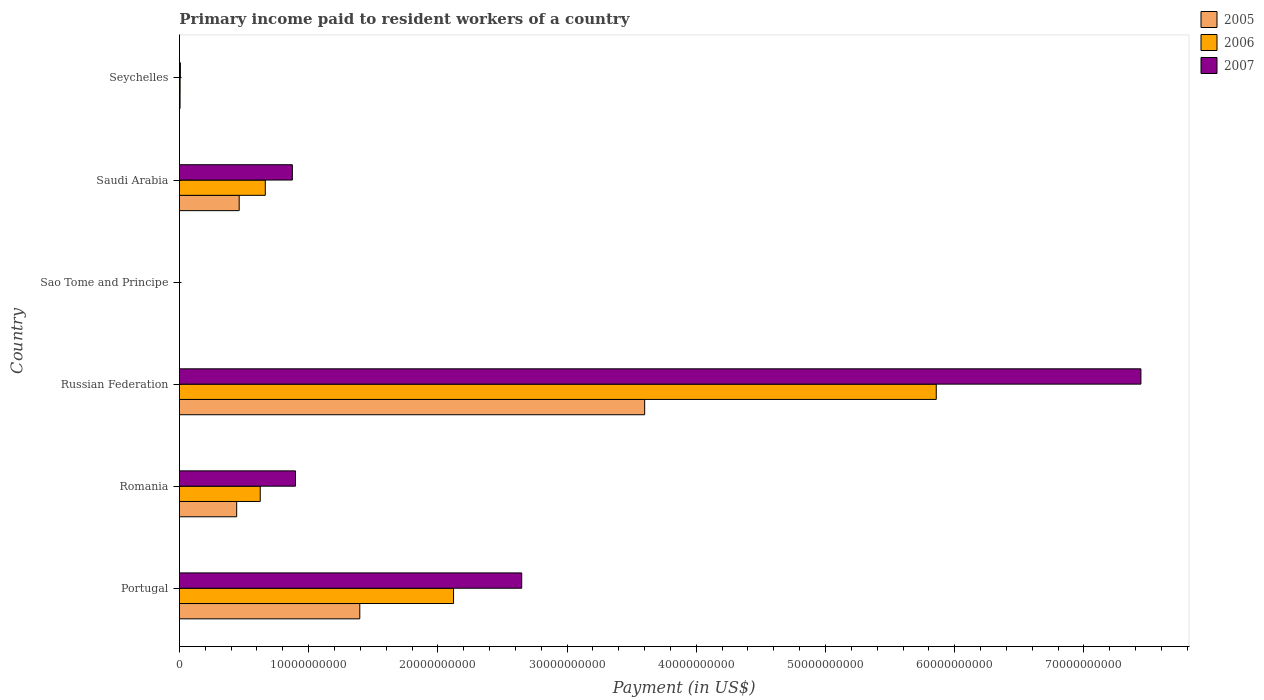How many different coloured bars are there?
Give a very brief answer. 3. How many groups of bars are there?
Ensure brevity in your answer.  6. Are the number of bars on each tick of the Y-axis equal?
Keep it short and to the point. Yes. How many bars are there on the 2nd tick from the top?
Provide a succinct answer. 3. What is the label of the 1st group of bars from the top?
Your answer should be compact. Seychelles. In how many cases, is the number of bars for a given country not equal to the number of legend labels?
Keep it short and to the point. 0. What is the amount paid to workers in 2006 in Romania?
Ensure brevity in your answer.  6.26e+09. Across all countries, what is the maximum amount paid to workers in 2007?
Provide a succinct answer. 7.44e+1. Across all countries, what is the minimum amount paid to workers in 2007?
Keep it short and to the point. 2.29e+06. In which country was the amount paid to workers in 2005 maximum?
Offer a very short reply. Russian Federation. In which country was the amount paid to workers in 2006 minimum?
Your response must be concise. Sao Tome and Principe. What is the total amount paid to workers in 2006 in the graph?
Ensure brevity in your answer.  9.27e+1. What is the difference between the amount paid to workers in 2006 in Saudi Arabia and that in Seychelles?
Give a very brief answer. 6.59e+09. What is the difference between the amount paid to workers in 2006 in Romania and the amount paid to workers in 2005 in Saudi Arabia?
Your response must be concise. 1.63e+09. What is the average amount paid to workers in 2006 per country?
Provide a succinct answer. 1.55e+1. What is the difference between the amount paid to workers in 2005 and amount paid to workers in 2007 in Seychelles?
Your answer should be very brief. -2.45e+07. What is the ratio of the amount paid to workers in 2005 in Romania to that in Sao Tome and Principe?
Provide a short and direct response. 905.04. Is the amount paid to workers in 2007 in Russian Federation less than that in Sao Tome and Principe?
Give a very brief answer. No. Is the difference between the amount paid to workers in 2005 in Romania and Saudi Arabia greater than the difference between the amount paid to workers in 2007 in Romania and Saudi Arabia?
Provide a short and direct response. No. What is the difference between the highest and the second highest amount paid to workers in 2005?
Offer a terse response. 2.20e+1. What is the difference between the highest and the lowest amount paid to workers in 2007?
Your response must be concise. 7.44e+1. Is the sum of the amount paid to workers in 2005 in Romania and Sao Tome and Principe greater than the maximum amount paid to workers in 2006 across all countries?
Ensure brevity in your answer.  No. What does the 2nd bar from the top in Saudi Arabia represents?
Ensure brevity in your answer.  2006. How many bars are there?
Keep it short and to the point. 18. What is the difference between two consecutive major ticks on the X-axis?
Ensure brevity in your answer.  1.00e+1. Are the values on the major ticks of X-axis written in scientific E-notation?
Offer a terse response. No. Where does the legend appear in the graph?
Offer a terse response. Top right. What is the title of the graph?
Provide a short and direct response. Primary income paid to resident workers of a country. What is the label or title of the X-axis?
Your response must be concise. Payment (in US$). What is the Payment (in US$) in 2005 in Portugal?
Your response must be concise. 1.40e+1. What is the Payment (in US$) of 2006 in Portugal?
Your answer should be compact. 2.12e+1. What is the Payment (in US$) in 2007 in Portugal?
Offer a terse response. 2.65e+1. What is the Payment (in US$) of 2005 in Romania?
Your answer should be compact. 4.43e+09. What is the Payment (in US$) of 2006 in Romania?
Provide a short and direct response. 6.26e+09. What is the Payment (in US$) in 2007 in Romania?
Offer a very short reply. 8.98e+09. What is the Payment (in US$) in 2005 in Russian Federation?
Offer a terse response. 3.60e+1. What is the Payment (in US$) in 2006 in Russian Federation?
Give a very brief answer. 5.86e+1. What is the Payment (in US$) in 2007 in Russian Federation?
Your answer should be very brief. 7.44e+1. What is the Payment (in US$) of 2005 in Sao Tome and Principe?
Provide a short and direct response. 4.90e+06. What is the Payment (in US$) in 2006 in Sao Tome and Principe?
Offer a very short reply. 3.12e+06. What is the Payment (in US$) in 2007 in Sao Tome and Principe?
Provide a short and direct response. 2.29e+06. What is the Payment (in US$) in 2005 in Saudi Arabia?
Your response must be concise. 4.63e+09. What is the Payment (in US$) of 2006 in Saudi Arabia?
Your answer should be compact. 6.65e+09. What is the Payment (in US$) of 2007 in Saudi Arabia?
Your response must be concise. 8.74e+09. What is the Payment (in US$) in 2005 in Seychelles?
Give a very brief answer. 4.99e+07. What is the Payment (in US$) in 2006 in Seychelles?
Offer a terse response. 5.39e+07. What is the Payment (in US$) in 2007 in Seychelles?
Make the answer very short. 7.44e+07. Across all countries, what is the maximum Payment (in US$) in 2005?
Your answer should be compact. 3.60e+1. Across all countries, what is the maximum Payment (in US$) of 2006?
Your answer should be very brief. 5.86e+1. Across all countries, what is the maximum Payment (in US$) of 2007?
Keep it short and to the point. 7.44e+1. Across all countries, what is the minimum Payment (in US$) of 2005?
Your response must be concise. 4.90e+06. Across all countries, what is the minimum Payment (in US$) of 2006?
Ensure brevity in your answer.  3.12e+06. Across all countries, what is the minimum Payment (in US$) of 2007?
Your answer should be very brief. 2.29e+06. What is the total Payment (in US$) in 2005 in the graph?
Your answer should be compact. 5.91e+1. What is the total Payment (in US$) of 2006 in the graph?
Your response must be concise. 9.27e+1. What is the total Payment (in US$) of 2007 in the graph?
Keep it short and to the point. 1.19e+11. What is the difference between the Payment (in US$) of 2005 in Portugal and that in Romania?
Offer a terse response. 9.53e+09. What is the difference between the Payment (in US$) in 2006 in Portugal and that in Romania?
Ensure brevity in your answer.  1.50e+1. What is the difference between the Payment (in US$) of 2007 in Portugal and that in Romania?
Keep it short and to the point. 1.75e+1. What is the difference between the Payment (in US$) of 2005 in Portugal and that in Russian Federation?
Provide a short and direct response. -2.20e+1. What is the difference between the Payment (in US$) in 2006 in Portugal and that in Russian Federation?
Give a very brief answer. -3.74e+1. What is the difference between the Payment (in US$) of 2007 in Portugal and that in Russian Federation?
Your response must be concise. -4.79e+1. What is the difference between the Payment (in US$) in 2005 in Portugal and that in Sao Tome and Principe?
Your answer should be compact. 1.40e+1. What is the difference between the Payment (in US$) of 2006 in Portugal and that in Sao Tome and Principe?
Your answer should be very brief. 2.12e+1. What is the difference between the Payment (in US$) of 2007 in Portugal and that in Sao Tome and Principe?
Your answer should be very brief. 2.65e+1. What is the difference between the Payment (in US$) of 2005 in Portugal and that in Saudi Arabia?
Keep it short and to the point. 9.33e+09. What is the difference between the Payment (in US$) of 2006 in Portugal and that in Saudi Arabia?
Your answer should be compact. 1.46e+1. What is the difference between the Payment (in US$) of 2007 in Portugal and that in Saudi Arabia?
Provide a succinct answer. 1.78e+1. What is the difference between the Payment (in US$) in 2005 in Portugal and that in Seychelles?
Provide a succinct answer. 1.39e+1. What is the difference between the Payment (in US$) of 2006 in Portugal and that in Seychelles?
Your answer should be compact. 2.12e+1. What is the difference between the Payment (in US$) of 2007 in Portugal and that in Seychelles?
Provide a short and direct response. 2.64e+1. What is the difference between the Payment (in US$) in 2005 in Romania and that in Russian Federation?
Make the answer very short. -3.16e+1. What is the difference between the Payment (in US$) in 2006 in Romania and that in Russian Federation?
Provide a succinct answer. -5.23e+1. What is the difference between the Payment (in US$) in 2007 in Romania and that in Russian Federation?
Give a very brief answer. -6.54e+1. What is the difference between the Payment (in US$) in 2005 in Romania and that in Sao Tome and Principe?
Give a very brief answer. 4.43e+09. What is the difference between the Payment (in US$) of 2006 in Romania and that in Sao Tome and Principe?
Offer a terse response. 6.25e+09. What is the difference between the Payment (in US$) in 2007 in Romania and that in Sao Tome and Principe?
Offer a terse response. 8.98e+09. What is the difference between the Payment (in US$) in 2005 in Romania and that in Saudi Arabia?
Your answer should be compact. -1.93e+08. What is the difference between the Payment (in US$) of 2006 in Romania and that in Saudi Arabia?
Make the answer very short. -3.91e+08. What is the difference between the Payment (in US$) of 2007 in Romania and that in Saudi Arabia?
Make the answer very short. 2.42e+08. What is the difference between the Payment (in US$) of 2005 in Romania and that in Seychelles?
Keep it short and to the point. 4.38e+09. What is the difference between the Payment (in US$) of 2006 in Romania and that in Seychelles?
Provide a succinct answer. 6.20e+09. What is the difference between the Payment (in US$) of 2007 in Romania and that in Seychelles?
Your answer should be compact. 8.91e+09. What is the difference between the Payment (in US$) in 2005 in Russian Federation and that in Sao Tome and Principe?
Your answer should be compact. 3.60e+1. What is the difference between the Payment (in US$) of 2006 in Russian Federation and that in Sao Tome and Principe?
Your answer should be compact. 5.86e+1. What is the difference between the Payment (in US$) in 2007 in Russian Federation and that in Sao Tome and Principe?
Make the answer very short. 7.44e+1. What is the difference between the Payment (in US$) of 2005 in Russian Federation and that in Saudi Arabia?
Keep it short and to the point. 3.14e+1. What is the difference between the Payment (in US$) in 2006 in Russian Federation and that in Saudi Arabia?
Offer a terse response. 5.19e+1. What is the difference between the Payment (in US$) of 2007 in Russian Federation and that in Saudi Arabia?
Ensure brevity in your answer.  6.57e+1. What is the difference between the Payment (in US$) in 2005 in Russian Federation and that in Seychelles?
Give a very brief answer. 3.60e+1. What is the difference between the Payment (in US$) of 2006 in Russian Federation and that in Seychelles?
Give a very brief answer. 5.85e+1. What is the difference between the Payment (in US$) of 2007 in Russian Federation and that in Seychelles?
Your response must be concise. 7.43e+1. What is the difference between the Payment (in US$) of 2005 in Sao Tome and Principe and that in Saudi Arabia?
Give a very brief answer. -4.62e+09. What is the difference between the Payment (in US$) of 2006 in Sao Tome and Principe and that in Saudi Arabia?
Ensure brevity in your answer.  -6.64e+09. What is the difference between the Payment (in US$) in 2007 in Sao Tome and Principe and that in Saudi Arabia?
Offer a very short reply. -8.74e+09. What is the difference between the Payment (in US$) of 2005 in Sao Tome and Principe and that in Seychelles?
Your answer should be very brief. -4.50e+07. What is the difference between the Payment (in US$) in 2006 in Sao Tome and Principe and that in Seychelles?
Your answer should be very brief. -5.08e+07. What is the difference between the Payment (in US$) of 2007 in Sao Tome and Principe and that in Seychelles?
Make the answer very short. -7.21e+07. What is the difference between the Payment (in US$) of 2005 in Saudi Arabia and that in Seychelles?
Provide a short and direct response. 4.58e+09. What is the difference between the Payment (in US$) in 2006 in Saudi Arabia and that in Seychelles?
Offer a very short reply. 6.59e+09. What is the difference between the Payment (in US$) in 2007 in Saudi Arabia and that in Seychelles?
Offer a terse response. 8.67e+09. What is the difference between the Payment (in US$) in 2005 in Portugal and the Payment (in US$) in 2006 in Romania?
Offer a terse response. 7.71e+09. What is the difference between the Payment (in US$) in 2005 in Portugal and the Payment (in US$) in 2007 in Romania?
Your response must be concise. 4.98e+09. What is the difference between the Payment (in US$) of 2006 in Portugal and the Payment (in US$) of 2007 in Romania?
Your answer should be very brief. 1.22e+1. What is the difference between the Payment (in US$) of 2005 in Portugal and the Payment (in US$) of 2006 in Russian Federation?
Your answer should be compact. -4.46e+1. What is the difference between the Payment (in US$) of 2005 in Portugal and the Payment (in US$) of 2007 in Russian Federation?
Offer a terse response. -6.05e+1. What is the difference between the Payment (in US$) in 2006 in Portugal and the Payment (in US$) in 2007 in Russian Federation?
Provide a succinct answer. -5.32e+1. What is the difference between the Payment (in US$) of 2005 in Portugal and the Payment (in US$) of 2006 in Sao Tome and Principe?
Make the answer very short. 1.40e+1. What is the difference between the Payment (in US$) of 2005 in Portugal and the Payment (in US$) of 2007 in Sao Tome and Principe?
Give a very brief answer. 1.40e+1. What is the difference between the Payment (in US$) of 2006 in Portugal and the Payment (in US$) of 2007 in Sao Tome and Principe?
Your answer should be very brief. 2.12e+1. What is the difference between the Payment (in US$) of 2005 in Portugal and the Payment (in US$) of 2006 in Saudi Arabia?
Give a very brief answer. 7.31e+09. What is the difference between the Payment (in US$) in 2005 in Portugal and the Payment (in US$) in 2007 in Saudi Arabia?
Ensure brevity in your answer.  5.22e+09. What is the difference between the Payment (in US$) in 2006 in Portugal and the Payment (in US$) in 2007 in Saudi Arabia?
Provide a succinct answer. 1.25e+1. What is the difference between the Payment (in US$) of 2005 in Portugal and the Payment (in US$) of 2006 in Seychelles?
Make the answer very short. 1.39e+1. What is the difference between the Payment (in US$) of 2005 in Portugal and the Payment (in US$) of 2007 in Seychelles?
Your answer should be compact. 1.39e+1. What is the difference between the Payment (in US$) of 2006 in Portugal and the Payment (in US$) of 2007 in Seychelles?
Provide a short and direct response. 2.11e+1. What is the difference between the Payment (in US$) of 2005 in Romania and the Payment (in US$) of 2006 in Russian Federation?
Offer a very short reply. -5.41e+1. What is the difference between the Payment (in US$) of 2005 in Romania and the Payment (in US$) of 2007 in Russian Federation?
Make the answer very short. -7.00e+1. What is the difference between the Payment (in US$) of 2006 in Romania and the Payment (in US$) of 2007 in Russian Federation?
Your answer should be very brief. -6.82e+1. What is the difference between the Payment (in US$) of 2005 in Romania and the Payment (in US$) of 2006 in Sao Tome and Principe?
Offer a terse response. 4.43e+09. What is the difference between the Payment (in US$) of 2005 in Romania and the Payment (in US$) of 2007 in Sao Tome and Principe?
Your response must be concise. 4.43e+09. What is the difference between the Payment (in US$) of 2006 in Romania and the Payment (in US$) of 2007 in Sao Tome and Principe?
Offer a very short reply. 6.25e+09. What is the difference between the Payment (in US$) of 2005 in Romania and the Payment (in US$) of 2006 in Saudi Arabia?
Provide a succinct answer. -2.21e+09. What is the difference between the Payment (in US$) in 2005 in Romania and the Payment (in US$) in 2007 in Saudi Arabia?
Provide a short and direct response. -4.31e+09. What is the difference between the Payment (in US$) of 2006 in Romania and the Payment (in US$) of 2007 in Saudi Arabia?
Provide a short and direct response. -2.49e+09. What is the difference between the Payment (in US$) of 2005 in Romania and the Payment (in US$) of 2006 in Seychelles?
Offer a terse response. 4.38e+09. What is the difference between the Payment (in US$) in 2005 in Romania and the Payment (in US$) in 2007 in Seychelles?
Make the answer very short. 4.36e+09. What is the difference between the Payment (in US$) in 2006 in Romania and the Payment (in US$) in 2007 in Seychelles?
Keep it short and to the point. 6.18e+09. What is the difference between the Payment (in US$) in 2005 in Russian Federation and the Payment (in US$) in 2006 in Sao Tome and Principe?
Offer a very short reply. 3.60e+1. What is the difference between the Payment (in US$) of 2005 in Russian Federation and the Payment (in US$) of 2007 in Sao Tome and Principe?
Offer a terse response. 3.60e+1. What is the difference between the Payment (in US$) in 2006 in Russian Federation and the Payment (in US$) in 2007 in Sao Tome and Principe?
Your answer should be compact. 5.86e+1. What is the difference between the Payment (in US$) in 2005 in Russian Federation and the Payment (in US$) in 2006 in Saudi Arabia?
Provide a short and direct response. 2.94e+1. What is the difference between the Payment (in US$) in 2005 in Russian Federation and the Payment (in US$) in 2007 in Saudi Arabia?
Give a very brief answer. 2.73e+1. What is the difference between the Payment (in US$) of 2006 in Russian Federation and the Payment (in US$) of 2007 in Saudi Arabia?
Your answer should be very brief. 4.98e+1. What is the difference between the Payment (in US$) of 2005 in Russian Federation and the Payment (in US$) of 2006 in Seychelles?
Your answer should be very brief. 3.60e+1. What is the difference between the Payment (in US$) in 2005 in Russian Federation and the Payment (in US$) in 2007 in Seychelles?
Offer a very short reply. 3.59e+1. What is the difference between the Payment (in US$) of 2006 in Russian Federation and the Payment (in US$) of 2007 in Seychelles?
Give a very brief answer. 5.85e+1. What is the difference between the Payment (in US$) in 2005 in Sao Tome and Principe and the Payment (in US$) in 2006 in Saudi Arabia?
Offer a terse response. -6.64e+09. What is the difference between the Payment (in US$) of 2005 in Sao Tome and Principe and the Payment (in US$) of 2007 in Saudi Arabia?
Provide a succinct answer. -8.74e+09. What is the difference between the Payment (in US$) of 2006 in Sao Tome and Principe and the Payment (in US$) of 2007 in Saudi Arabia?
Provide a succinct answer. -8.74e+09. What is the difference between the Payment (in US$) in 2005 in Sao Tome and Principe and the Payment (in US$) in 2006 in Seychelles?
Provide a short and direct response. -4.90e+07. What is the difference between the Payment (in US$) of 2005 in Sao Tome and Principe and the Payment (in US$) of 2007 in Seychelles?
Your answer should be very brief. -6.95e+07. What is the difference between the Payment (in US$) of 2006 in Sao Tome and Principe and the Payment (in US$) of 2007 in Seychelles?
Your response must be concise. -7.13e+07. What is the difference between the Payment (in US$) of 2005 in Saudi Arabia and the Payment (in US$) of 2006 in Seychelles?
Ensure brevity in your answer.  4.57e+09. What is the difference between the Payment (in US$) in 2005 in Saudi Arabia and the Payment (in US$) in 2007 in Seychelles?
Ensure brevity in your answer.  4.55e+09. What is the difference between the Payment (in US$) in 2006 in Saudi Arabia and the Payment (in US$) in 2007 in Seychelles?
Your answer should be compact. 6.57e+09. What is the average Payment (in US$) of 2005 per country?
Keep it short and to the point. 9.85e+09. What is the average Payment (in US$) in 2006 per country?
Your response must be concise. 1.55e+1. What is the average Payment (in US$) in 2007 per country?
Keep it short and to the point. 1.98e+1. What is the difference between the Payment (in US$) of 2005 and Payment (in US$) of 2006 in Portugal?
Provide a short and direct response. -7.25e+09. What is the difference between the Payment (in US$) in 2005 and Payment (in US$) in 2007 in Portugal?
Ensure brevity in your answer.  -1.25e+1. What is the difference between the Payment (in US$) in 2006 and Payment (in US$) in 2007 in Portugal?
Offer a very short reply. -5.28e+09. What is the difference between the Payment (in US$) in 2005 and Payment (in US$) in 2006 in Romania?
Your answer should be very brief. -1.82e+09. What is the difference between the Payment (in US$) of 2005 and Payment (in US$) of 2007 in Romania?
Provide a short and direct response. -4.55e+09. What is the difference between the Payment (in US$) of 2006 and Payment (in US$) of 2007 in Romania?
Provide a succinct answer. -2.73e+09. What is the difference between the Payment (in US$) of 2005 and Payment (in US$) of 2006 in Russian Federation?
Provide a short and direct response. -2.26e+1. What is the difference between the Payment (in US$) in 2005 and Payment (in US$) in 2007 in Russian Federation?
Offer a terse response. -3.84e+1. What is the difference between the Payment (in US$) of 2006 and Payment (in US$) of 2007 in Russian Federation?
Offer a very short reply. -1.58e+1. What is the difference between the Payment (in US$) of 2005 and Payment (in US$) of 2006 in Sao Tome and Principe?
Provide a short and direct response. 1.78e+06. What is the difference between the Payment (in US$) of 2005 and Payment (in US$) of 2007 in Sao Tome and Principe?
Provide a short and direct response. 2.61e+06. What is the difference between the Payment (in US$) of 2006 and Payment (in US$) of 2007 in Sao Tome and Principe?
Make the answer very short. 8.31e+05. What is the difference between the Payment (in US$) in 2005 and Payment (in US$) in 2006 in Saudi Arabia?
Make the answer very short. -2.02e+09. What is the difference between the Payment (in US$) in 2005 and Payment (in US$) in 2007 in Saudi Arabia?
Offer a terse response. -4.12e+09. What is the difference between the Payment (in US$) of 2006 and Payment (in US$) of 2007 in Saudi Arabia?
Give a very brief answer. -2.09e+09. What is the difference between the Payment (in US$) in 2005 and Payment (in US$) in 2006 in Seychelles?
Provide a succinct answer. -4.01e+06. What is the difference between the Payment (in US$) in 2005 and Payment (in US$) in 2007 in Seychelles?
Ensure brevity in your answer.  -2.45e+07. What is the difference between the Payment (in US$) of 2006 and Payment (in US$) of 2007 in Seychelles?
Give a very brief answer. -2.05e+07. What is the ratio of the Payment (in US$) in 2005 in Portugal to that in Romania?
Keep it short and to the point. 3.15. What is the ratio of the Payment (in US$) in 2006 in Portugal to that in Romania?
Provide a short and direct response. 3.39. What is the ratio of the Payment (in US$) of 2007 in Portugal to that in Romania?
Your response must be concise. 2.95. What is the ratio of the Payment (in US$) of 2005 in Portugal to that in Russian Federation?
Ensure brevity in your answer.  0.39. What is the ratio of the Payment (in US$) in 2006 in Portugal to that in Russian Federation?
Provide a short and direct response. 0.36. What is the ratio of the Payment (in US$) in 2007 in Portugal to that in Russian Federation?
Provide a short and direct response. 0.36. What is the ratio of the Payment (in US$) of 2005 in Portugal to that in Sao Tome and Principe?
Make the answer very short. 2850.57. What is the ratio of the Payment (in US$) of 2006 in Portugal to that in Sao Tome and Principe?
Your answer should be very brief. 6797.73. What is the ratio of the Payment (in US$) of 2007 in Portugal to that in Sao Tome and Principe?
Make the answer very short. 1.16e+04. What is the ratio of the Payment (in US$) of 2005 in Portugal to that in Saudi Arabia?
Provide a succinct answer. 3.02. What is the ratio of the Payment (in US$) in 2006 in Portugal to that in Saudi Arabia?
Make the answer very short. 3.19. What is the ratio of the Payment (in US$) in 2007 in Portugal to that in Saudi Arabia?
Offer a very short reply. 3.03. What is the ratio of the Payment (in US$) of 2005 in Portugal to that in Seychelles?
Ensure brevity in your answer.  279.9. What is the ratio of the Payment (in US$) of 2006 in Portugal to that in Seychelles?
Provide a succinct answer. 393.67. What is the ratio of the Payment (in US$) in 2007 in Portugal to that in Seychelles?
Your answer should be compact. 355.95. What is the ratio of the Payment (in US$) of 2005 in Romania to that in Russian Federation?
Keep it short and to the point. 0.12. What is the ratio of the Payment (in US$) in 2006 in Romania to that in Russian Federation?
Your response must be concise. 0.11. What is the ratio of the Payment (in US$) in 2007 in Romania to that in Russian Federation?
Offer a very short reply. 0.12. What is the ratio of the Payment (in US$) of 2005 in Romania to that in Sao Tome and Principe?
Provide a short and direct response. 905.04. What is the ratio of the Payment (in US$) of 2006 in Romania to that in Sao Tome and Principe?
Your answer should be compact. 2004.32. What is the ratio of the Payment (in US$) of 2007 in Romania to that in Sao Tome and Principe?
Offer a terse response. 3922.77. What is the ratio of the Payment (in US$) in 2005 in Romania to that in Saudi Arabia?
Keep it short and to the point. 0.96. What is the ratio of the Payment (in US$) of 2007 in Romania to that in Saudi Arabia?
Offer a terse response. 1.03. What is the ratio of the Payment (in US$) in 2005 in Romania to that in Seychelles?
Your answer should be very brief. 88.87. What is the ratio of the Payment (in US$) in 2006 in Romania to that in Seychelles?
Offer a terse response. 116.07. What is the ratio of the Payment (in US$) of 2007 in Romania to that in Seychelles?
Offer a terse response. 120.7. What is the ratio of the Payment (in US$) in 2005 in Russian Federation to that in Sao Tome and Principe?
Your answer should be compact. 7352.32. What is the ratio of the Payment (in US$) in 2006 in Russian Federation to that in Sao Tome and Principe?
Provide a succinct answer. 1.88e+04. What is the ratio of the Payment (in US$) of 2007 in Russian Federation to that in Sao Tome and Principe?
Your answer should be very brief. 3.25e+04. What is the ratio of the Payment (in US$) in 2005 in Russian Federation to that in Saudi Arabia?
Offer a terse response. 7.78. What is the ratio of the Payment (in US$) of 2006 in Russian Federation to that in Saudi Arabia?
Ensure brevity in your answer.  8.81. What is the ratio of the Payment (in US$) of 2007 in Russian Federation to that in Saudi Arabia?
Provide a succinct answer. 8.51. What is the ratio of the Payment (in US$) in 2005 in Russian Federation to that in Seychelles?
Keep it short and to the point. 721.92. What is the ratio of the Payment (in US$) in 2006 in Russian Federation to that in Seychelles?
Keep it short and to the point. 1086.89. What is the ratio of the Payment (in US$) of 2007 in Russian Federation to that in Seychelles?
Provide a succinct answer. 999.84. What is the ratio of the Payment (in US$) in 2005 in Sao Tome and Principe to that in Saudi Arabia?
Make the answer very short. 0. What is the ratio of the Payment (in US$) in 2007 in Sao Tome and Principe to that in Saudi Arabia?
Offer a very short reply. 0. What is the ratio of the Payment (in US$) of 2005 in Sao Tome and Principe to that in Seychelles?
Offer a terse response. 0.1. What is the ratio of the Payment (in US$) of 2006 in Sao Tome and Principe to that in Seychelles?
Your answer should be very brief. 0.06. What is the ratio of the Payment (in US$) of 2007 in Sao Tome and Principe to that in Seychelles?
Make the answer very short. 0.03. What is the ratio of the Payment (in US$) in 2005 in Saudi Arabia to that in Seychelles?
Your answer should be very brief. 92.74. What is the ratio of the Payment (in US$) of 2006 in Saudi Arabia to that in Seychelles?
Provide a succinct answer. 123.33. What is the ratio of the Payment (in US$) in 2007 in Saudi Arabia to that in Seychelles?
Make the answer very short. 117.45. What is the difference between the highest and the second highest Payment (in US$) in 2005?
Offer a very short reply. 2.20e+1. What is the difference between the highest and the second highest Payment (in US$) of 2006?
Make the answer very short. 3.74e+1. What is the difference between the highest and the second highest Payment (in US$) in 2007?
Your response must be concise. 4.79e+1. What is the difference between the highest and the lowest Payment (in US$) of 2005?
Provide a short and direct response. 3.60e+1. What is the difference between the highest and the lowest Payment (in US$) in 2006?
Give a very brief answer. 5.86e+1. What is the difference between the highest and the lowest Payment (in US$) in 2007?
Your answer should be very brief. 7.44e+1. 